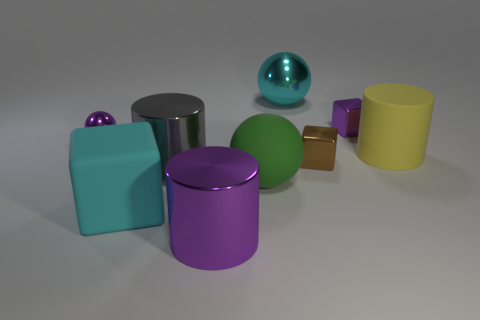What number of objects are either large blocks or big objects on the left side of the large cyan metal sphere?
Your answer should be compact. 4. Are there fewer big gray metal things than small blue rubber things?
Make the answer very short. No. The ball that is behind the cube that is behind the yellow rubber cylinder is what color?
Your response must be concise. Cyan. There is another tiny object that is the same shape as the small brown object; what is it made of?
Provide a short and direct response. Metal. How many rubber things are big objects or tiny purple objects?
Give a very brief answer. 3. Do the tiny brown object in front of the big metallic sphere and the big cyan thing behind the gray metallic cylinder have the same material?
Provide a succinct answer. Yes. Are any tiny blue rubber objects visible?
Keep it short and to the point. No. Does the big metal object that is behind the large matte cylinder have the same shape as the small purple object to the right of the large purple shiny cylinder?
Give a very brief answer. No. Is there a small red ball that has the same material as the big purple cylinder?
Provide a short and direct response. No. Is the material of the cyan thing on the left side of the cyan metal thing the same as the small purple block?
Offer a very short reply. No. 